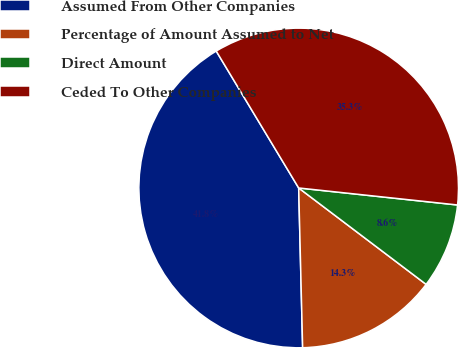Convert chart to OTSL. <chart><loc_0><loc_0><loc_500><loc_500><pie_chart><fcel>Assumed From Other Companies<fcel>Percentage of Amount Assumed to Net<fcel>Direct Amount<fcel>Ceded To Other Companies<nl><fcel>41.77%<fcel>14.3%<fcel>8.61%<fcel>35.33%<nl></chart> 